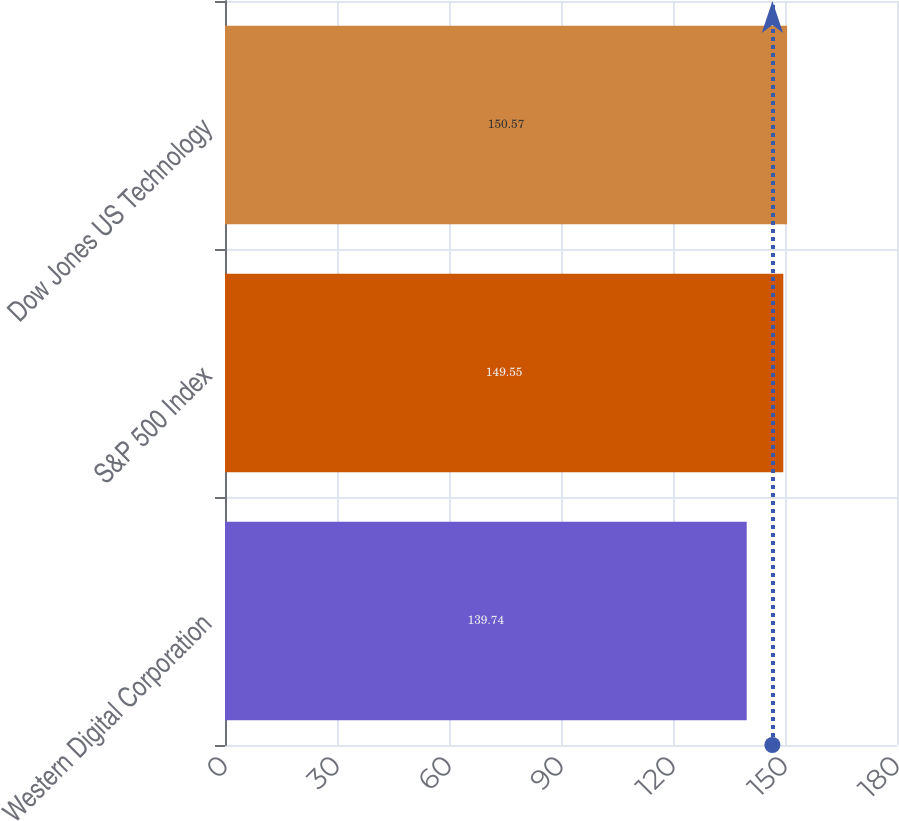<chart> <loc_0><loc_0><loc_500><loc_500><bar_chart><fcel>Western Digital Corporation<fcel>S&P 500 Index<fcel>Dow Jones US Technology<nl><fcel>139.74<fcel>149.55<fcel>150.57<nl></chart> 